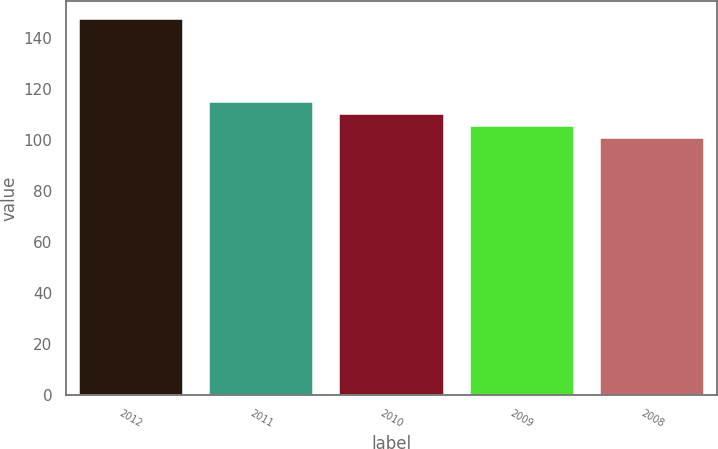Convert chart to OTSL. <chart><loc_0><loc_0><loc_500><loc_500><bar_chart><fcel>2012<fcel>2011<fcel>2010<fcel>2009<fcel>2008<nl><fcel>147.28<fcel>114.76<fcel>110.12<fcel>105.48<fcel>100.84<nl></chart> 